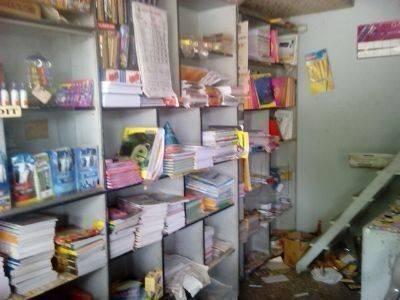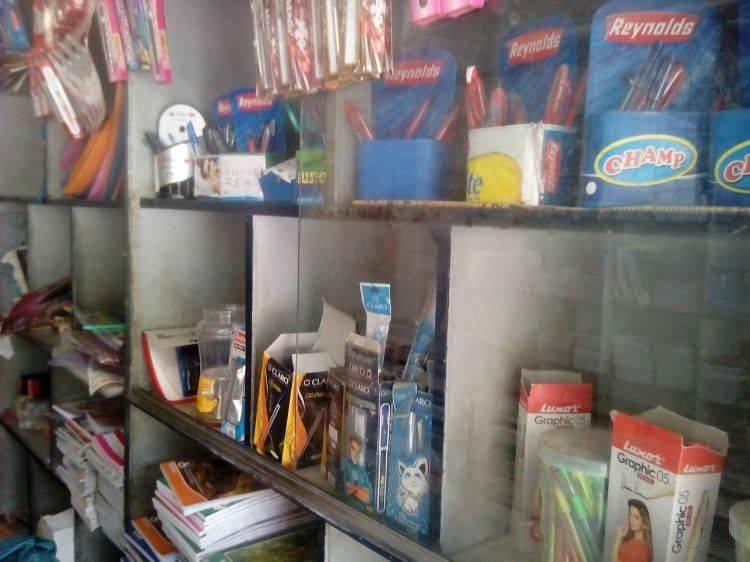The first image is the image on the left, the second image is the image on the right. Evaluate the accuracy of this statement regarding the images: "There are three men with black hair and brown skin inside a bookstore.". Is it true? Answer yes or no. No. The first image is the image on the left, the second image is the image on the right. Examine the images to the left and right. Is the description "There are people standing." accurate? Answer yes or no. No. 